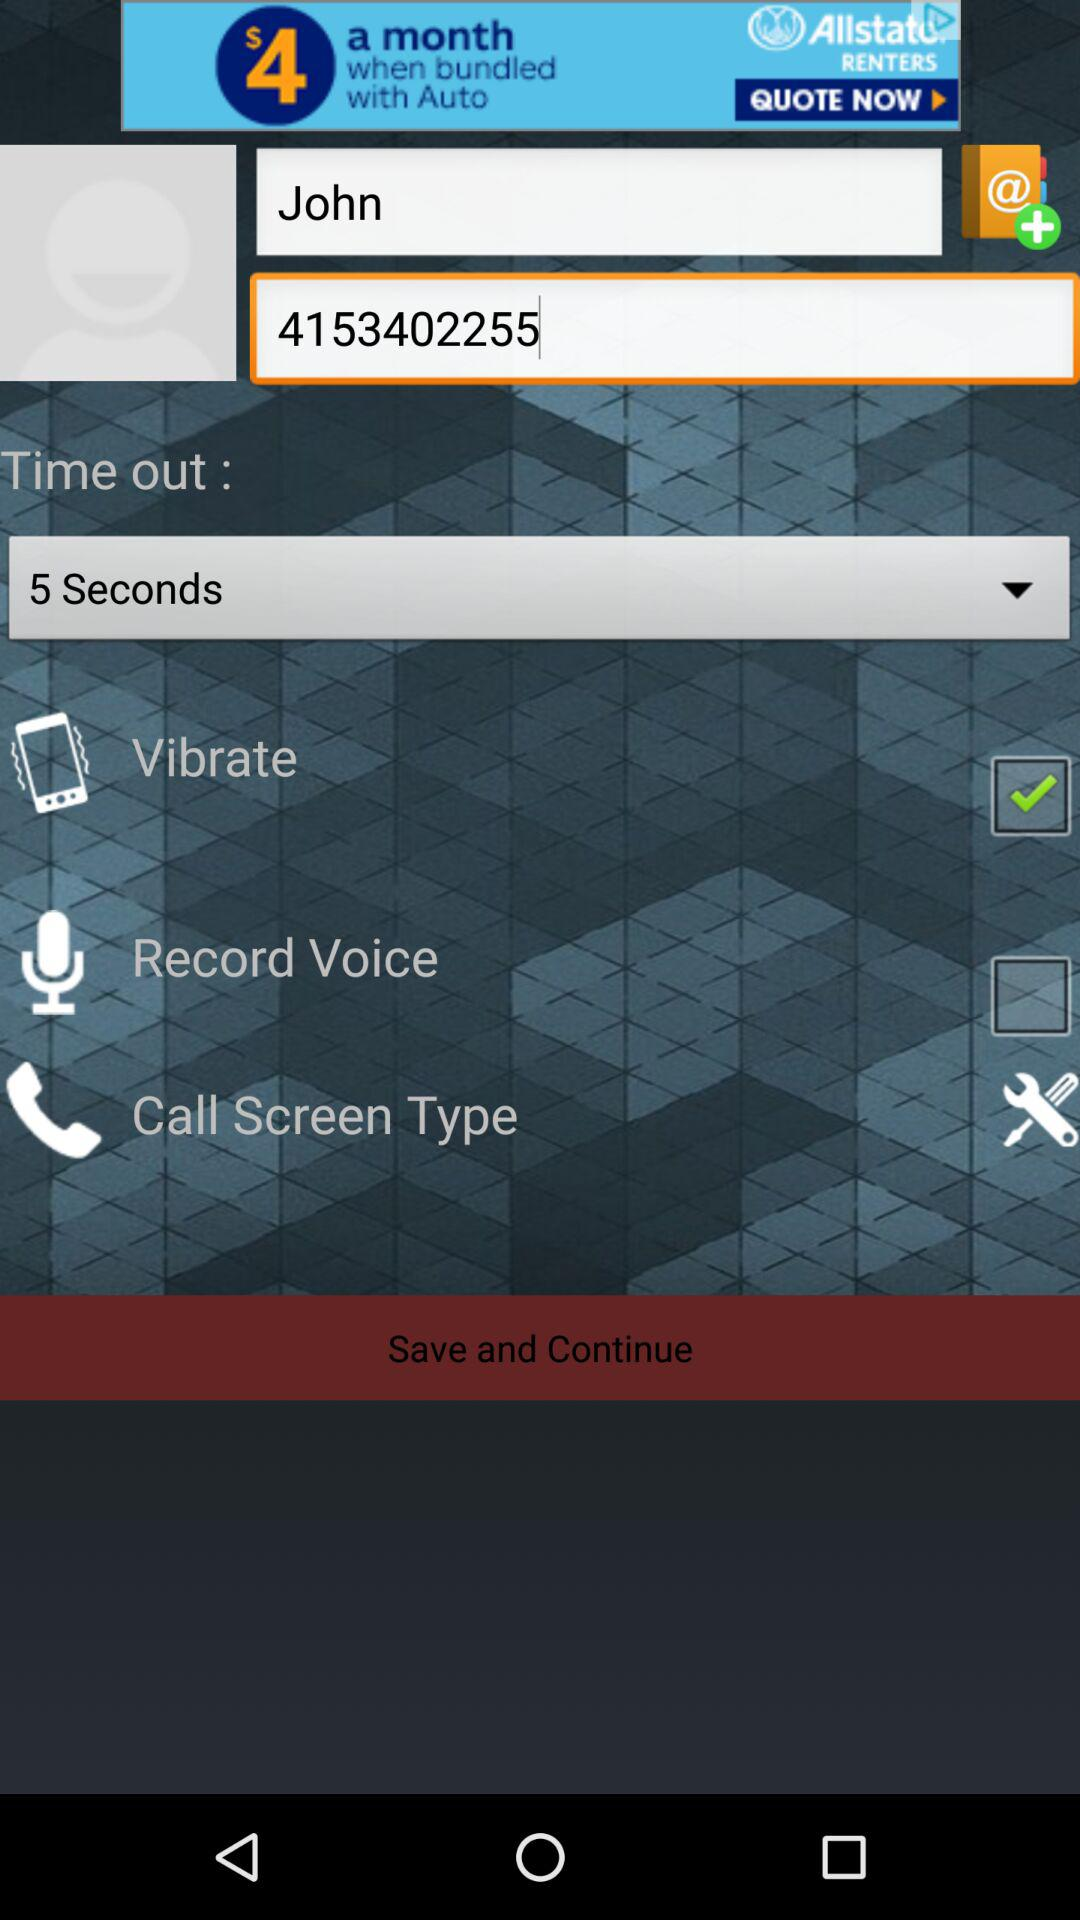What is the status of "Record Voice"? The status of "Record Voice" is "off". 